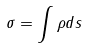<formula> <loc_0><loc_0><loc_500><loc_500>\sigma = \int \rho d s</formula> 